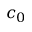Convert formula to latex. <formula><loc_0><loc_0><loc_500><loc_500>c _ { 0 }</formula> 